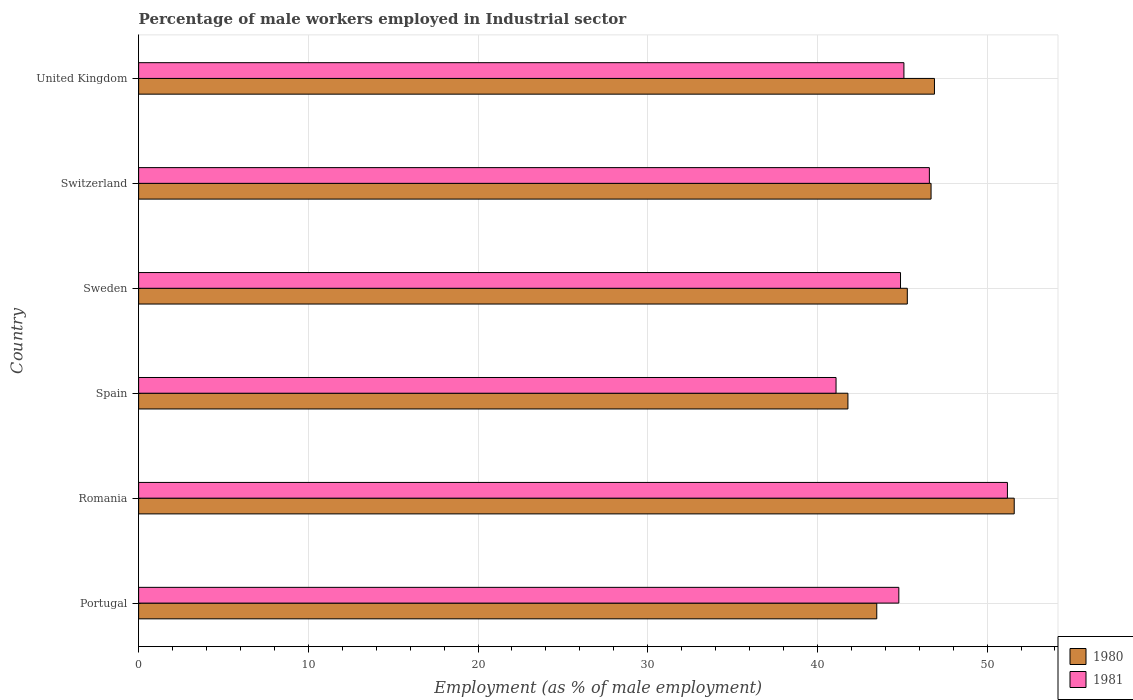Are the number of bars per tick equal to the number of legend labels?
Make the answer very short. Yes. How many bars are there on the 1st tick from the top?
Provide a succinct answer. 2. How many bars are there on the 6th tick from the bottom?
Give a very brief answer. 2. What is the label of the 4th group of bars from the top?
Provide a succinct answer. Spain. What is the percentage of male workers employed in Industrial sector in 1980 in Sweden?
Make the answer very short. 45.3. Across all countries, what is the maximum percentage of male workers employed in Industrial sector in 1980?
Offer a very short reply. 51.6. Across all countries, what is the minimum percentage of male workers employed in Industrial sector in 1981?
Your answer should be very brief. 41.1. In which country was the percentage of male workers employed in Industrial sector in 1980 maximum?
Your answer should be compact. Romania. What is the total percentage of male workers employed in Industrial sector in 1981 in the graph?
Give a very brief answer. 273.7. What is the difference between the percentage of male workers employed in Industrial sector in 1980 in Portugal and that in United Kingdom?
Make the answer very short. -3.4. What is the difference between the percentage of male workers employed in Industrial sector in 1981 in Spain and the percentage of male workers employed in Industrial sector in 1980 in United Kingdom?
Provide a short and direct response. -5.8. What is the average percentage of male workers employed in Industrial sector in 1981 per country?
Your answer should be compact. 45.62. What is the difference between the percentage of male workers employed in Industrial sector in 1980 and percentage of male workers employed in Industrial sector in 1981 in Switzerland?
Provide a short and direct response. 0.1. What is the ratio of the percentage of male workers employed in Industrial sector in 1980 in Romania to that in Switzerland?
Your response must be concise. 1.1. Is the percentage of male workers employed in Industrial sector in 1980 in Sweden less than that in Switzerland?
Provide a short and direct response. Yes. Is the difference between the percentage of male workers employed in Industrial sector in 1980 in Portugal and Sweden greater than the difference between the percentage of male workers employed in Industrial sector in 1981 in Portugal and Sweden?
Provide a succinct answer. No. What is the difference between the highest and the second highest percentage of male workers employed in Industrial sector in 1980?
Your answer should be very brief. 4.7. What is the difference between the highest and the lowest percentage of male workers employed in Industrial sector in 1980?
Ensure brevity in your answer.  9.8. What is the difference between two consecutive major ticks on the X-axis?
Offer a terse response. 10. Does the graph contain grids?
Provide a succinct answer. Yes. Where does the legend appear in the graph?
Keep it short and to the point. Bottom right. What is the title of the graph?
Provide a short and direct response. Percentage of male workers employed in Industrial sector. What is the label or title of the X-axis?
Your answer should be very brief. Employment (as % of male employment). What is the label or title of the Y-axis?
Your response must be concise. Country. What is the Employment (as % of male employment) in 1980 in Portugal?
Your answer should be very brief. 43.5. What is the Employment (as % of male employment) in 1981 in Portugal?
Your response must be concise. 44.8. What is the Employment (as % of male employment) in 1980 in Romania?
Your response must be concise. 51.6. What is the Employment (as % of male employment) of 1981 in Romania?
Offer a very short reply. 51.2. What is the Employment (as % of male employment) of 1980 in Spain?
Offer a very short reply. 41.8. What is the Employment (as % of male employment) in 1981 in Spain?
Ensure brevity in your answer.  41.1. What is the Employment (as % of male employment) in 1980 in Sweden?
Provide a short and direct response. 45.3. What is the Employment (as % of male employment) in 1981 in Sweden?
Offer a very short reply. 44.9. What is the Employment (as % of male employment) of 1980 in Switzerland?
Offer a terse response. 46.7. What is the Employment (as % of male employment) of 1981 in Switzerland?
Provide a short and direct response. 46.6. What is the Employment (as % of male employment) in 1980 in United Kingdom?
Provide a succinct answer. 46.9. What is the Employment (as % of male employment) in 1981 in United Kingdom?
Provide a succinct answer. 45.1. Across all countries, what is the maximum Employment (as % of male employment) of 1980?
Keep it short and to the point. 51.6. Across all countries, what is the maximum Employment (as % of male employment) of 1981?
Keep it short and to the point. 51.2. Across all countries, what is the minimum Employment (as % of male employment) of 1980?
Ensure brevity in your answer.  41.8. Across all countries, what is the minimum Employment (as % of male employment) of 1981?
Give a very brief answer. 41.1. What is the total Employment (as % of male employment) of 1980 in the graph?
Your answer should be compact. 275.8. What is the total Employment (as % of male employment) in 1981 in the graph?
Provide a succinct answer. 273.7. What is the difference between the Employment (as % of male employment) of 1980 in Portugal and that in Romania?
Provide a short and direct response. -8.1. What is the difference between the Employment (as % of male employment) in 1980 in Portugal and that in Spain?
Provide a succinct answer. 1.7. What is the difference between the Employment (as % of male employment) of 1980 in Portugal and that in Sweden?
Your answer should be compact. -1.8. What is the difference between the Employment (as % of male employment) of 1981 in Portugal and that in Sweden?
Provide a short and direct response. -0.1. What is the difference between the Employment (as % of male employment) of 1981 in Romania and that in Spain?
Make the answer very short. 10.1. What is the difference between the Employment (as % of male employment) in 1981 in Romania and that in Switzerland?
Your response must be concise. 4.6. What is the difference between the Employment (as % of male employment) in 1980 in Spain and that in United Kingdom?
Give a very brief answer. -5.1. What is the difference between the Employment (as % of male employment) in 1981 in Spain and that in United Kingdom?
Offer a very short reply. -4. What is the difference between the Employment (as % of male employment) of 1981 in Sweden and that in Switzerland?
Make the answer very short. -1.7. What is the difference between the Employment (as % of male employment) of 1981 in Sweden and that in United Kingdom?
Give a very brief answer. -0.2. What is the difference between the Employment (as % of male employment) in 1980 in Switzerland and that in United Kingdom?
Your answer should be compact. -0.2. What is the difference between the Employment (as % of male employment) in 1980 in Portugal and the Employment (as % of male employment) in 1981 in Spain?
Offer a terse response. 2.4. What is the difference between the Employment (as % of male employment) in 1980 in Portugal and the Employment (as % of male employment) in 1981 in Switzerland?
Offer a very short reply. -3.1. What is the difference between the Employment (as % of male employment) of 1980 in Romania and the Employment (as % of male employment) of 1981 in Spain?
Make the answer very short. 10.5. What is the difference between the Employment (as % of male employment) of 1980 in Romania and the Employment (as % of male employment) of 1981 in Switzerland?
Keep it short and to the point. 5. What is the difference between the Employment (as % of male employment) in 1980 in Romania and the Employment (as % of male employment) in 1981 in United Kingdom?
Ensure brevity in your answer.  6.5. What is the difference between the Employment (as % of male employment) in 1980 in Spain and the Employment (as % of male employment) in 1981 in Sweden?
Ensure brevity in your answer.  -3.1. What is the difference between the Employment (as % of male employment) in 1980 in Switzerland and the Employment (as % of male employment) in 1981 in United Kingdom?
Provide a succinct answer. 1.6. What is the average Employment (as % of male employment) of 1980 per country?
Your response must be concise. 45.97. What is the average Employment (as % of male employment) of 1981 per country?
Make the answer very short. 45.62. What is the difference between the Employment (as % of male employment) in 1980 and Employment (as % of male employment) in 1981 in Spain?
Offer a terse response. 0.7. What is the difference between the Employment (as % of male employment) in 1980 and Employment (as % of male employment) in 1981 in Sweden?
Make the answer very short. 0.4. What is the difference between the Employment (as % of male employment) in 1980 and Employment (as % of male employment) in 1981 in United Kingdom?
Your answer should be compact. 1.8. What is the ratio of the Employment (as % of male employment) in 1980 in Portugal to that in Romania?
Provide a short and direct response. 0.84. What is the ratio of the Employment (as % of male employment) of 1980 in Portugal to that in Spain?
Give a very brief answer. 1.04. What is the ratio of the Employment (as % of male employment) in 1981 in Portugal to that in Spain?
Make the answer very short. 1.09. What is the ratio of the Employment (as % of male employment) in 1980 in Portugal to that in Sweden?
Your answer should be very brief. 0.96. What is the ratio of the Employment (as % of male employment) of 1981 in Portugal to that in Sweden?
Offer a terse response. 1. What is the ratio of the Employment (as % of male employment) in 1980 in Portugal to that in Switzerland?
Provide a succinct answer. 0.93. What is the ratio of the Employment (as % of male employment) of 1981 in Portugal to that in Switzerland?
Make the answer very short. 0.96. What is the ratio of the Employment (as % of male employment) of 1980 in Portugal to that in United Kingdom?
Offer a terse response. 0.93. What is the ratio of the Employment (as % of male employment) of 1981 in Portugal to that in United Kingdom?
Your response must be concise. 0.99. What is the ratio of the Employment (as % of male employment) of 1980 in Romania to that in Spain?
Make the answer very short. 1.23. What is the ratio of the Employment (as % of male employment) of 1981 in Romania to that in Spain?
Provide a short and direct response. 1.25. What is the ratio of the Employment (as % of male employment) of 1980 in Romania to that in Sweden?
Ensure brevity in your answer.  1.14. What is the ratio of the Employment (as % of male employment) in 1981 in Romania to that in Sweden?
Make the answer very short. 1.14. What is the ratio of the Employment (as % of male employment) in 1980 in Romania to that in Switzerland?
Offer a terse response. 1.1. What is the ratio of the Employment (as % of male employment) of 1981 in Romania to that in Switzerland?
Give a very brief answer. 1.1. What is the ratio of the Employment (as % of male employment) in 1980 in Romania to that in United Kingdom?
Your answer should be compact. 1.1. What is the ratio of the Employment (as % of male employment) in 1981 in Romania to that in United Kingdom?
Your response must be concise. 1.14. What is the ratio of the Employment (as % of male employment) of 1980 in Spain to that in Sweden?
Provide a succinct answer. 0.92. What is the ratio of the Employment (as % of male employment) in 1981 in Spain to that in Sweden?
Offer a very short reply. 0.92. What is the ratio of the Employment (as % of male employment) of 1980 in Spain to that in Switzerland?
Give a very brief answer. 0.9. What is the ratio of the Employment (as % of male employment) in 1981 in Spain to that in Switzerland?
Ensure brevity in your answer.  0.88. What is the ratio of the Employment (as % of male employment) of 1980 in Spain to that in United Kingdom?
Give a very brief answer. 0.89. What is the ratio of the Employment (as % of male employment) in 1981 in Spain to that in United Kingdom?
Offer a very short reply. 0.91. What is the ratio of the Employment (as % of male employment) of 1981 in Sweden to that in Switzerland?
Your answer should be very brief. 0.96. What is the ratio of the Employment (as % of male employment) of 1980 in Sweden to that in United Kingdom?
Keep it short and to the point. 0.97. What is the ratio of the Employment (as % of male employment) of 1981 in Sweden to that in United Kingdom?
Your answer should be compact. 1. What is the difference between the highest and the lowest Employment (as % of male employment) of 1980?
Provide a short and direct response. 9.8. 